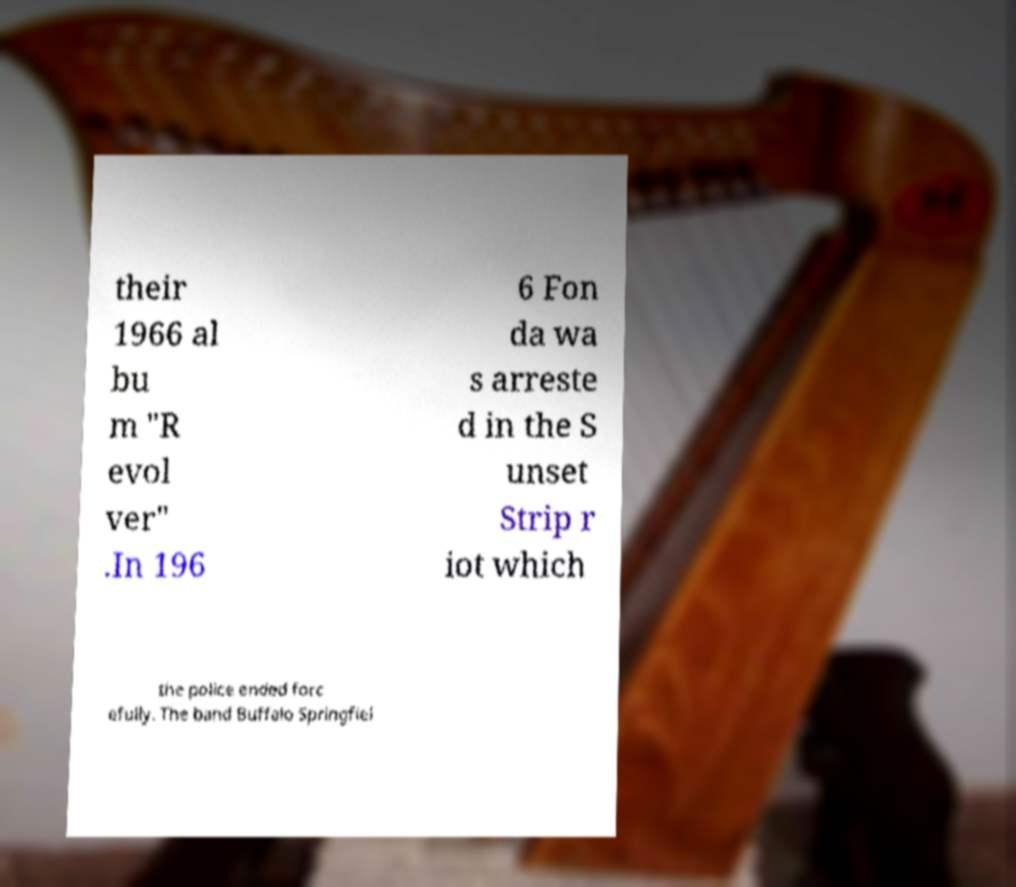Can you read and provide the text displayed in the image?This photo seems to have some interesting text. Can you extract and type it out for me? their 1966 al bu m "R evol ver" .In 196 6 Fon da wa s arreste d in the S unset Strip r iot which the police ended forc efully. The band Buffalo Springfiel 